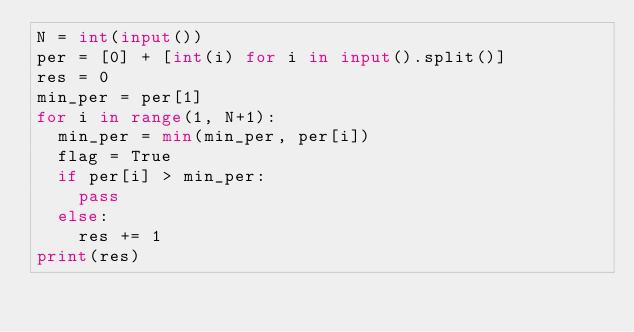Convert code to text. <code><loc_0><loc_0><loc_500><loc_500><_Python_>N = int(input())
per = [0] + [int(i) for i in input().split()]
res = 0
min_per = per[1]
for i in range(1, N+1):
  min_per = min(min_per, per[i])
  flag = True
  if per[i] > min_per: 
    pass
  else: 
    res += 1
print(res)</code> 